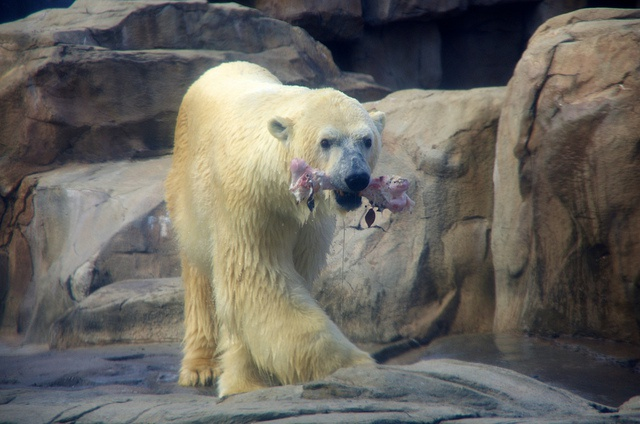Describe the objects in this image and their specific colors. I can see a bear in black, tan, and gray tones in this image. 